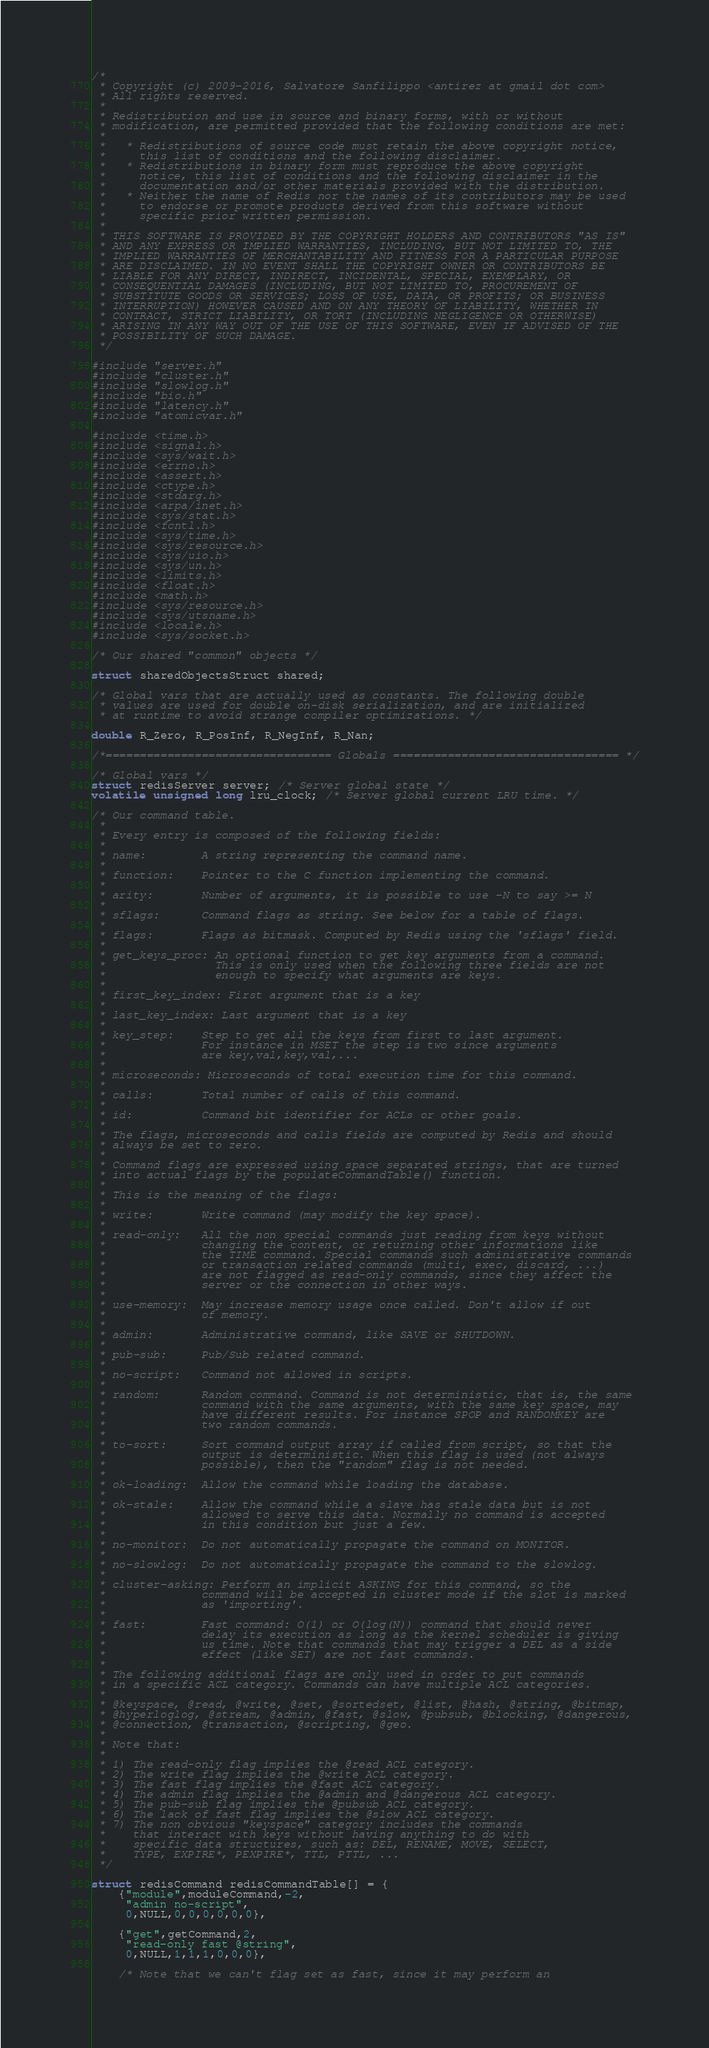<code> <loc_0><loc_0><loc_500><loc_500><_C_>/*
 * Copyright (c) 2009-2016, Salvatore Sanfilippo <antirez at gmail dot com>
 * All rights reserved.
 *
 * Redistribution and use in source and binary forms, with or without
 * modification, are permitted provided that the following conditions are met:
 *
 *   * Redistributions of source code must retain the above copyright notice,
 *     this list of conditions and the following disclaimer.
 *   * Redistributions in binary form must reproduce the above copyright
 *     notice, this list of conditions and the following disclaimer in the
 *     documentation and/or other materials provided with the distribution.
 *   * Neither the name of Redis nor the names of its contributors may be used
 *     to endorse or promote products derived from this software without
 *     specific prior written permission.
 *
 * THIS SOFTWARE IS PROVIDED BY THE COPYRIGHT HOLDERS AND CONTRIBUTORS "AS IS"
 * AND ANY EXPRESS OR IMPLIED WARRANTIES, INCLUDING, BUT NOT LIMITED TO, THE
 * IMPLIED WARRANTIES OF MERCHANTABILITY AND FITNESS FOR A PARTICULAR PURPOSE
 * ARE DISCLAIMED. IN NO EVENT SHALL THE COPYRIGHT OWNER OR CONTRIBUTORS BE
 * LIABLE FOR ANY DIRECT, INDIRECT, INCIDENTAL, SPECIAL, EXEMPLARY, OR
 * CONSEQUENTIAL DAMAGES (INCLUDING, BUT NOT LIMITED TO, PROCUREMENT OF
 * SUBSTITUTE GOODS OR SERVICES; LOSS OF USE, DATA, OR PROFITS; OR BUSINESS
 * INTERRUPTION) HOWEVER CAUSED AND ON ANY THEORY OF LIABILITY, WHETHER IN
 * CONTRACT, STRICT LIABILITY, OR TORT (INCLUDING NEGLIGENCE OR OTHERWISE)
 * ARISING IN ANY WAY OUT OF THE USE OF THIS SOFTWARE, EVEN IF ADVISED OF THE
 * POSSIBILITY OF SUCH DAMAGE.
 */

#include "server.h"
#include "cluster.h"
#include "slowlog.h"
#include "bio.h"
#include "latency.h"
#include "atomicvar.h"

#include <time.h>
#include <signal.h>
#include <sys/wait.h>
#include <errno.h>
#include <assert.h>
#include <ctype.h>
#include <stdarg.h>
#include <arpa/inet.h>
#include <sys/stat.h>
#include <fcntl.h>
#include <sys/time.h>
#include <sys/resource.h>
#include <sys/uio.h>
#include <sys/un.h>
#include <limits.h>
#include <float.h>
#include <math.h>
#include <sys/resource.h>
#include <sys/utsname.h>
#include <locale.h>
#include <sys/socket.h>

/* Our shared "common" objects */

struct sharedObjectsStruct shared;

/* Global vars that are actually used as constants. The following double
 * values are used for double on-disk serialization, and are initialized
 * at runtime to avoid strange compiler optimizations. */

double R_Zero, R_PosInf, R_NegInf, R_Nan;

/*================================= Globals ================================= */

/* Global vars */
struct redisServer server; /* Server global state */
volatile unsigned long lru_clock; /* Server global current LRU time. */

/* Our command table.
 *
 * Every entry is composed of the following fields:
 *
 * name:        A string representing the command name.
 *
 * function:    Pointer to the C function implementing the command.
 *
 * arity:       Number of arguments, it is possible to use -N to say >= N
 *
 * sflags:      Command flags as string. See below for a table of flags.
 *
 * flags:       Flags as bitmask. Computed by Redis using the 'sflags' field.
 *
 * get_keys_proc: An optional function to get key arguments from a command.
 *                This is only used when the following three fields are not
 *                enough to specify what arguments are keys.
 *
 * first_key_index: First argument that is a key
 *
 * last_key_index: Last argument that is a key
 *
 * key_step:    Step to get all the keys from first to last argument.
 *              For instance in MSET the step is two since arguments
 *              are key,val,key,val,...
 *
 * microseconds: Microseconds of total execution time for this command.
 *
 * calls:       Total number of calls of this command.
 *
 * id:          Command bit identifier for ACLs or other goals.
 *
 * The flags, microseconds and calls fields are computed by Redis and should
 * always be set to zero.
 *
 * Command flags are expressed using space separated strings, that are turned
 * into actual flags by the populateCommandTable() function.
 *
 * This is the meaning of the flags:
 *
 * write:       Write command (may modify the key space).
 *
 * read-only:   All the non special commands just reading from keys without
 *              changing the content, or returning other informations like
 *              the TIME command. Special commands such administrative commands
 *              or transaction related commands (multi, exec, discard, ...)
 *              are not flagged as read-only commands, since they affect the
 *              server or the connection in other ways.
 *
 * use-memory:  May increase memory usage once called. Don't allow if out
 *              of memory.
 *
 * admin:       Administrative command, like SAVE or SHUTDOWN.
 *
 * pub-sub:     Pub/Sub related command.
 *
 * no-script:   Command not allowed in scripts.
 *
 * random:      Random command. Command is not deterministic, that is, the same
 *              command with the same arguments, with the same key space, may
 *              have different results. For instance SPOP and RANDOMKEY are
 *              two random commands.
 *
 * to-sort:     Sort command output array if called from script, so that the
 *              output is deterministic. When this flag is used (not always
 *              possible), then the "random" flag is not needed.
 *
 * ok-loading:  Allow the command while loading the database.
 *
 * ok-stale:    Allow the command while a slave has stale data but is not
 *              allowed to serve this data. Normally no command is accepted
 *              in this condition but just a few.
 *
 * no-monitor:  Do not automatically propagate the command on MONITOR.
 *
 * no-slowlog:  Do not automatically propagate the command to the slowlog.
 *
 * cluster-asking: Perform an implicit ASKING for this command, so the
 *              command will be accepted in cluster mode if the slot is marked
 *              as 'importing'.
 *
 * fast:        Fast command: O(1) or O(log(N)) command that should never
 *              delay its execution as long as the kernel scheduler is giving
 *              us time. Note that commands that may trigger a DEL as a side
 *              effect (like SET) are not fast commands.
 *
 * The following additional flags are only used in order to put commands
 * in a specific ACL category. Commands can have multiple ACL categories.
 *
 * @keyspace, @read, @write, @set, @sortedset, @list, @hash, @string, @bitmap,
 * @hyperloglog, @stream, @admin, @fast, @slow, @pubsub, @blocking, @dangerous,
 * @connection, @transaction, @scripting, @geo.
 *
 * Note that:
 *
 * 1) The read-only flag implies the @read ACL category.
 * 2) The write flag implies the @write ACL category.
 * 3) The fast flag implies the @fast ACL category.
 * 4) The admin flag implies the @admin and @dangerous ACL category.
 * 5) The pub-sub flag implies the @pubsub ACL category.
 * 6) The lack of fast flag implies the @slow ACL category.
 * 7) The non obvious "keyspace" category includes the commands
 *    that interact with keys without having anything to do with
 *    specific data structures, such as: DEL, RENAME, MOVE, SELECT,
 *    TYPE, EXPIRE*, PEXPIRE*, TTL, PTTL, ...
 */

struct redisCommand redisCommandTable[] = {
    {"module",moduleCommand,-2,
     "admin no-script",
     0,NULL,0,0,0,0,0,0},

    {"get",getCommand,2,
     "read-only fast @string",
     0,NULL,1,1,1,0,0,0},

    /* Note that we can't flag set as fast, since it may perform an</code> 